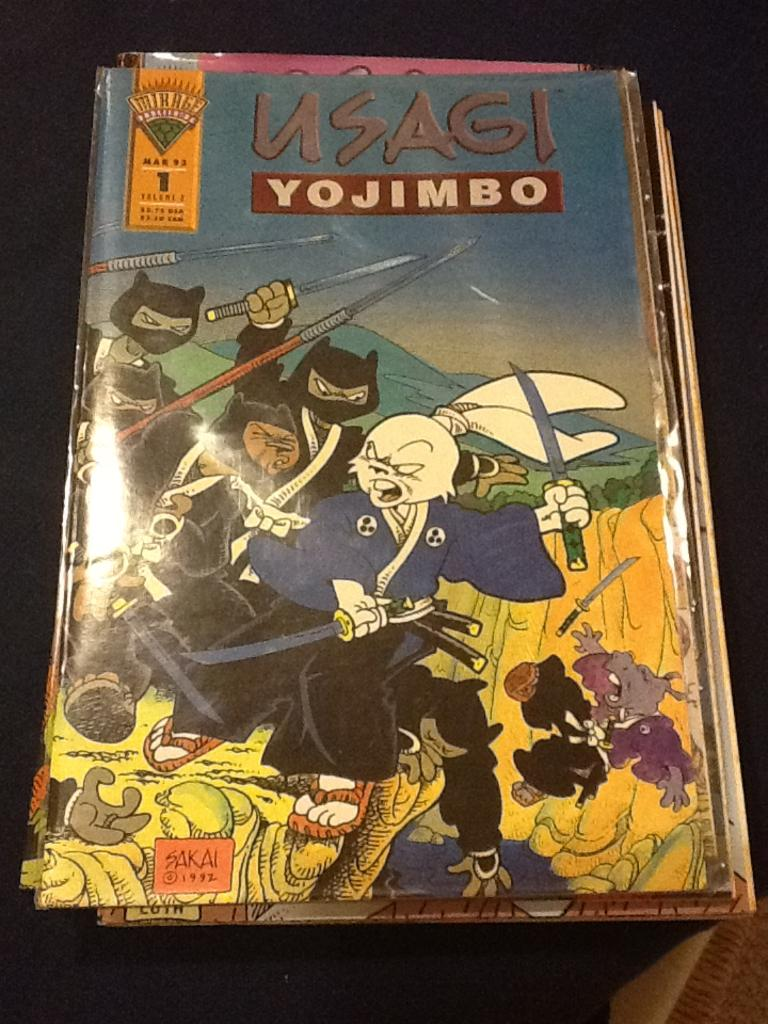Provide a one-sentence caption for the provided image. Usagi Yojimbo comic book with animals with swords. 